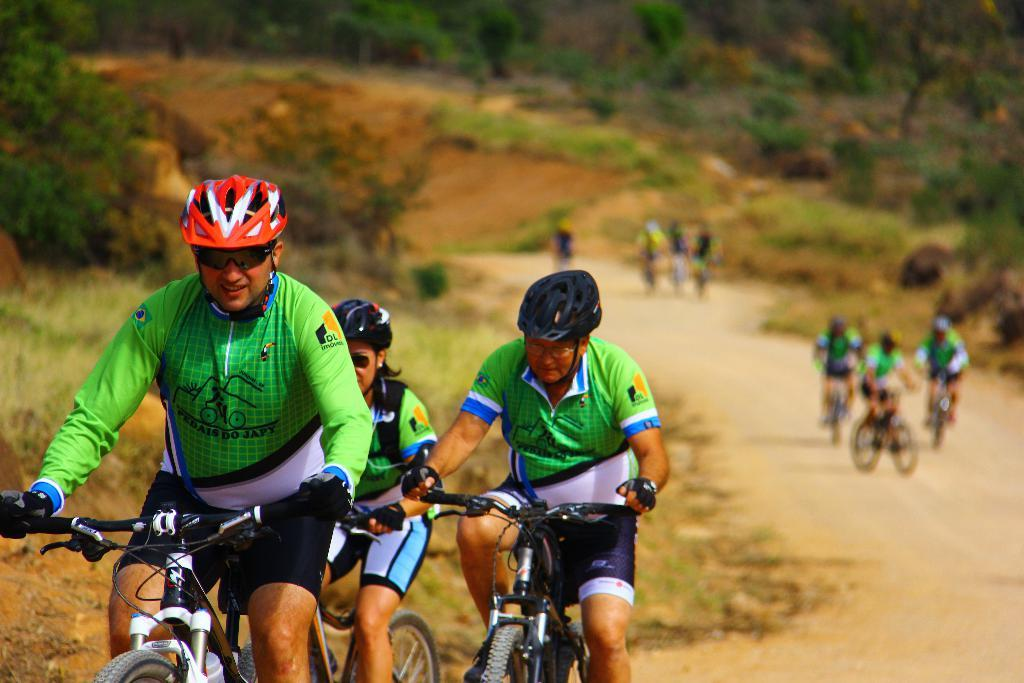What are the people in the image doing? The people in the image are riding bicycles. Where are the people riding their bicycles? The bicycles are on a road. What can be seen in the background behind the group of people? There are trees visible behind the group of people. What type of ball is being used by the dinosaurs in the image? There are no dinosaurs or balls present in the image; it features a group of people riding bicycles on a road with trees in the background. 